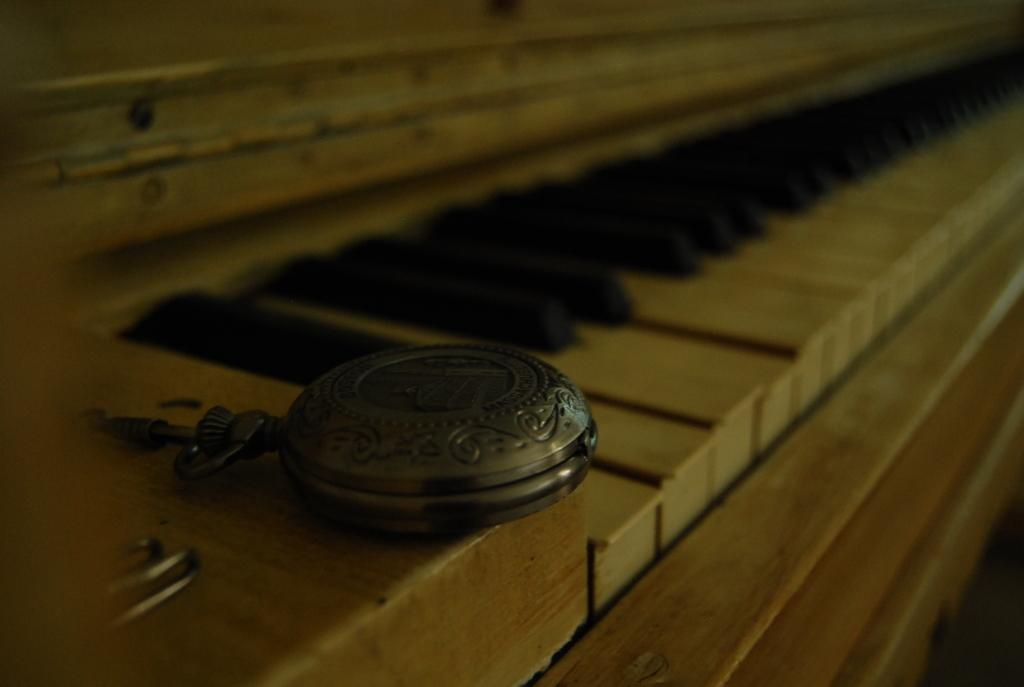What is the main object in the image? There is a piano in the image. Is there anything placed on the piano? Yes, there is an object kept on the piano. Where is the ocean located in the image? There is no ocean present in the image; it only features a piano with an object on it. 